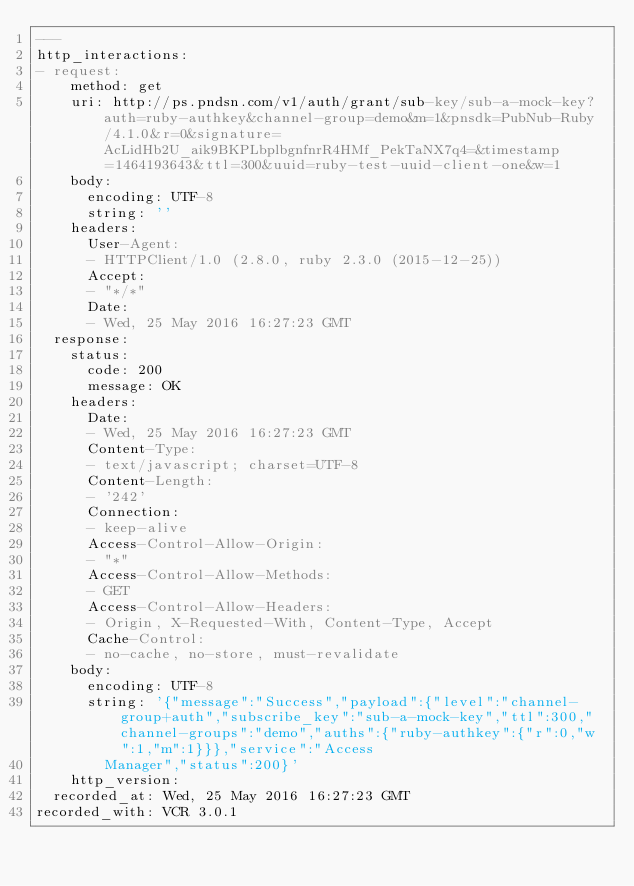Convert code to text. <code><loc_0><loc_0><loc_500><loc_500><_YAML_>---
http_interactions:
- request:
    method: get
    uri: http://ps.pndsn.com/v1/auth/grant/sub-key/sub-a-mock-key?auth=ruby-authkey&channel-group=demo&m=1&pnsdk=PubNub-Ruby/4.1.0&r=0&signature=AcLidHb2U_aik9BKPLbplbgnfnrR4HMf_PekTaNX7q4=&timestamp=1464193643&ttl=300&uuid=ruby-test-uuid-client-one&w=1
    body:
      encoding: UTF-8
      string: ''
    headers:
      User-Agent:
      - HTTPClient/1.0 (2.8.0, ruby 2.3.0 (2015-12-25))
      Accept:
      - "*/*"
      Date:
      - Wed, 25 May 2016 16:27:23 GMT
  response:
    status:
      code: 200
      message: OK
    headers:
      Date:
      - Wed, 25 May 2016 16:27:23 GMT
      Content-Type:
      - text/javascript; charset=UTF-8
      Content-Length:
      - '242'
      Connection:
      - keep-alive
      Access-Control-Allow-Origin:
      - "*"
      Access-Control-Allow-Methods:
      - GET
      Access-Control-Allow-Headers:
      - Origin, X-Requested-With, Content-Type, Accept
      Cache-Control:
      - no-cache, no-store, must-revalidate
    body:
      encoding: UTF-8
      string: '{"message":"Success","payload":{"level":"channel-group+auth","subscribe_key":"sub-a-mock-key","ttl":300,"channel-groups":"demo","auths":{"ruby-authkey":{"r":0,"w":1,"m":1}}},"service":"Access
        Manager","status":200}'
    http_version: 
  recorded_at: Wed, 25 May 2016 16:27:23 GMT
recorded_with: VCR 3.0.1
</code> 